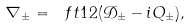<formula> <loc_0><loc_0><loc_500><loc_500>\nabla _ { \pm } = \ f t { 1 } { 2 } ( \mathcal { D } _ { \pm } - i Q _ { \pm } ) ,</formula> 